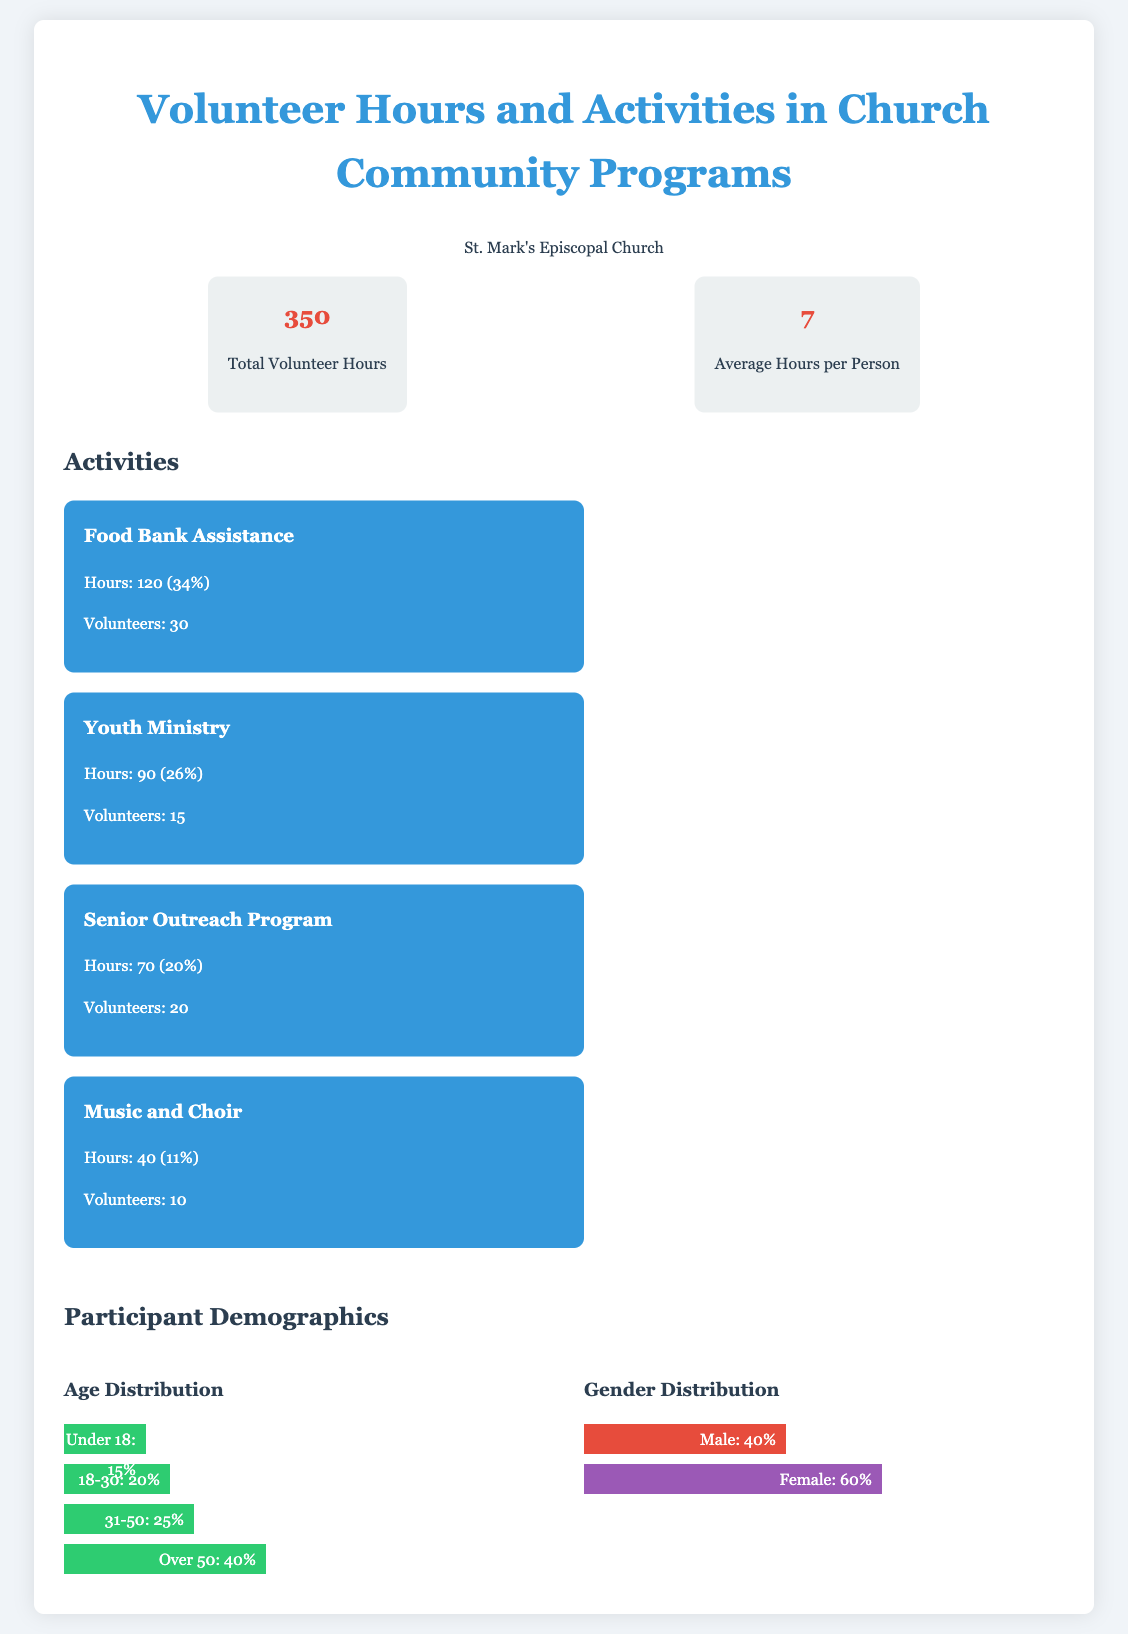What is the total number of volunteer hours? The total number of volunteer hours is indicated in the overview section of the document.
Answer: 350 What percentage of total hours were spent on Food Bank Assistance? The Food Bank Assistance activity is listed with its respective hours and percentage in the activities section.
Answer: 34% How many volunteers participated in the Senior Outreach Program? The number of volunteers for each activity is specified in the activities section.
Answer: 20 What is the average number of hours volunteers contributed per person? The average hours per person is provided in the overview section.
Answer: 7 What age group has the highest representation among participants? The age distribution is shown in the demographics section, highlighting the largest percentage.
Answer: Over 50 What is the percentage of female participants in the church programs? The gender distribution data is present in the demographics section, indicating the percentage for each gender.
Answer: 60% Which activity had the least number of volunteer hours? By comparing the hours spent on each activity listed in the activities section, we can identify the one with the least hours.
Answer: Music and Choir How many activities are listed in the document? The activities section enumerates the various activities, which can be counted to find the total.
Answer: 4 What proportion of volunteers participated in the Youth Ministry? The number of volunteers for the Youth Ministry is specified in the activities section relative to the total number of volunteers.
Answer: 15 